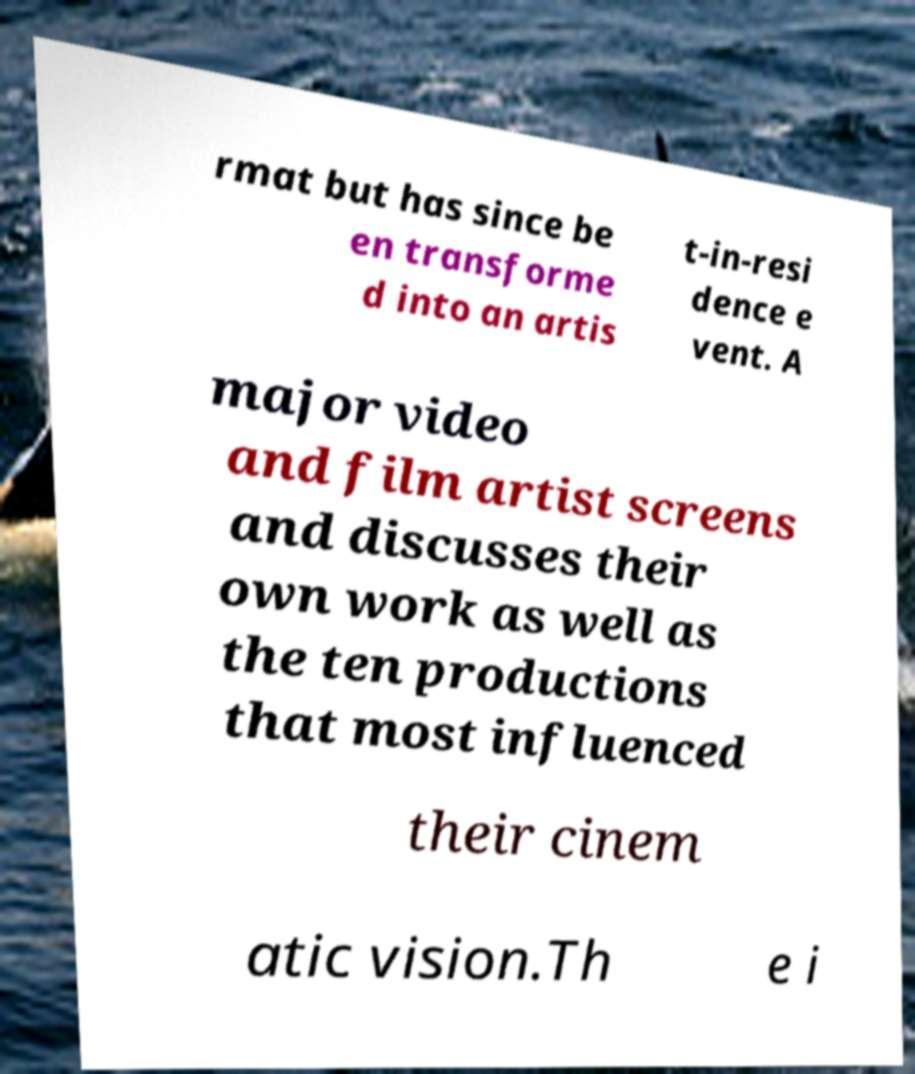Please read and relay the text visible in this image. What does it say? rmat but has since be en transforme d into an artis t-in-resi dence e vent. A major video and film artist screens and discusses their own work as well as the ten productions that most influenced their cinem atic vision.Th e i 